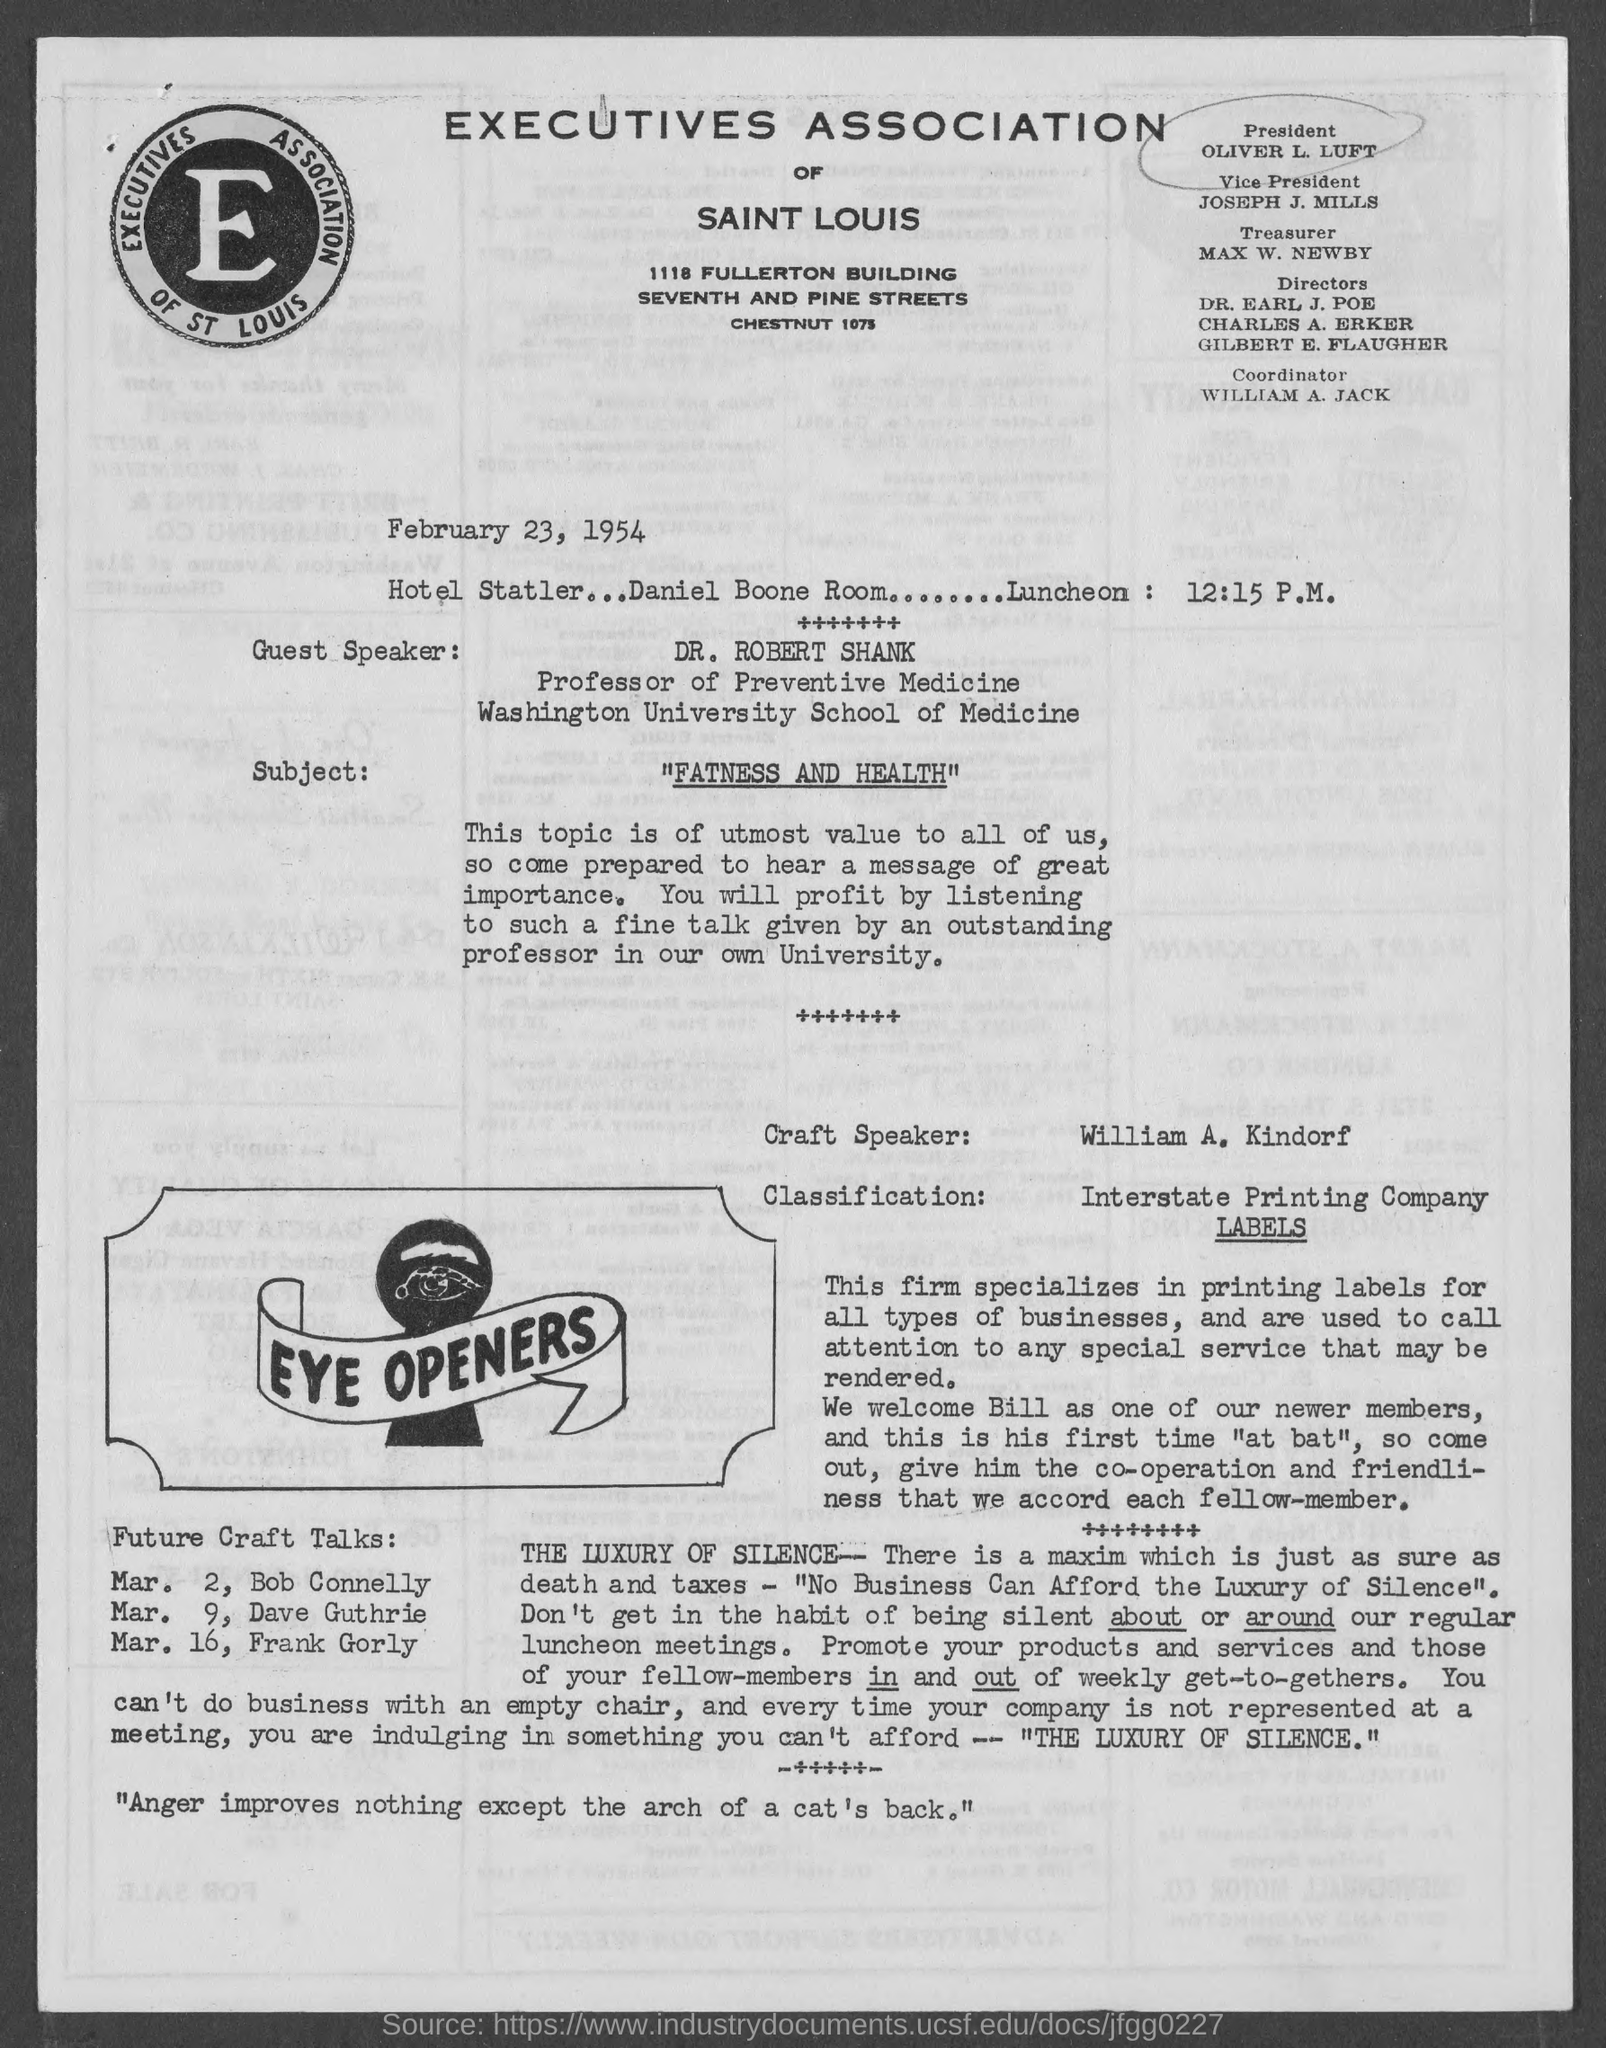Specify some key components in this picture. MAX W. NEWBY is the treasurer. The coordinator is William A. Jackson. The document is dated February 23, 1954. William A. Kindorf is the Craft Speaker. Oliver L. Luft is the current president. 